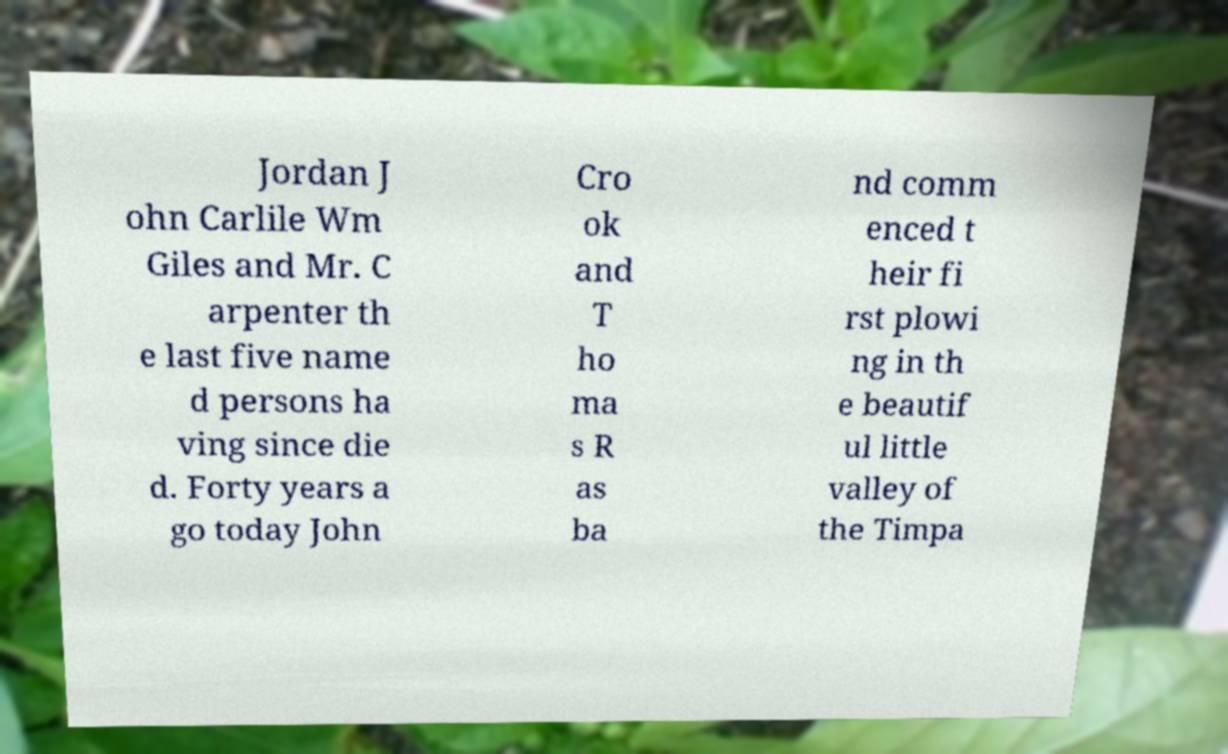For documentation purposes, I need the text within this image transcribed. Could you provide that? Jordan J ohn Carlile Wm Giles and Mr. C arpenter th e last five name d persons ha ving since die d. Forty years a go today John Cro ok and T ho ma s R as ba nd comm enced t heir fi rst plowi ng in th e beautif ul little valley of the Timpa 